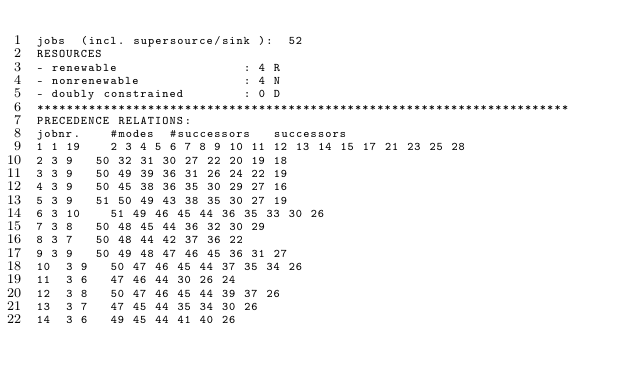<code> <loc_0><loc_0><loc_500><loc_500><_ObjectiveC_>jobs  (incl. supersource/sink ):	52
RESOURCES
- renewable                 : 4 R
- nonrenewable              : 4 N
- doubly constrained        : 0 D
************************************************************************
PRECEDENCE RELATIONS:
jobnr.    #modes  #successors   successors
1	1	19		2 3 4 5 6 7 8 9 10 11 12 13 14 15 17 21 23 25 28 
2	3	9		50 32 31 30 27 22 20 19 18 
3	3	9		50 49 39 36 31 26 24 22 19 
4	3	9		50 45 38 36 35 30 29 27 16 
5	3	9		51 50 49 43 38 35 30 27 19 
6	3	10		51 49 46 45 44 36 35 33 30 26 
7	3	8		50 48 45 44 36 32 30 29 
8	3	7		50 48 44 42 37 36 22 
9	3	9		50 49 48 47 46 45 36 31 27 
10	3	9		50 47 46 45 44 37 35 34 26 
11	3	6		47 46 44 30 26 24 
12	3	8		50 47 46 45 44 39 37 26 
13	3	7		47 45 44 35 34 30 26 
14	3	6		49 45 44 41 40 26 </code> 